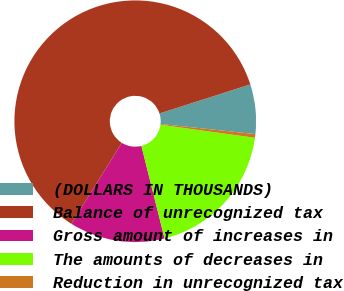Convert chart. <chart><loc_0><loc_0><loc_500><loc_500><pie_chart><fcel>(DOLLARS IN THOUSANDS)<fcel>Balance of unrecognized tax<fcel>Gross amount of increases in<fcel>The amounts of decreases in<fcel>Reduction in unrecognized tax<nl><fcel>6.63%<fcel>61.2%<fcel>12.77%<fcel>18.91%<fcel>0.49%<nl></chart> 